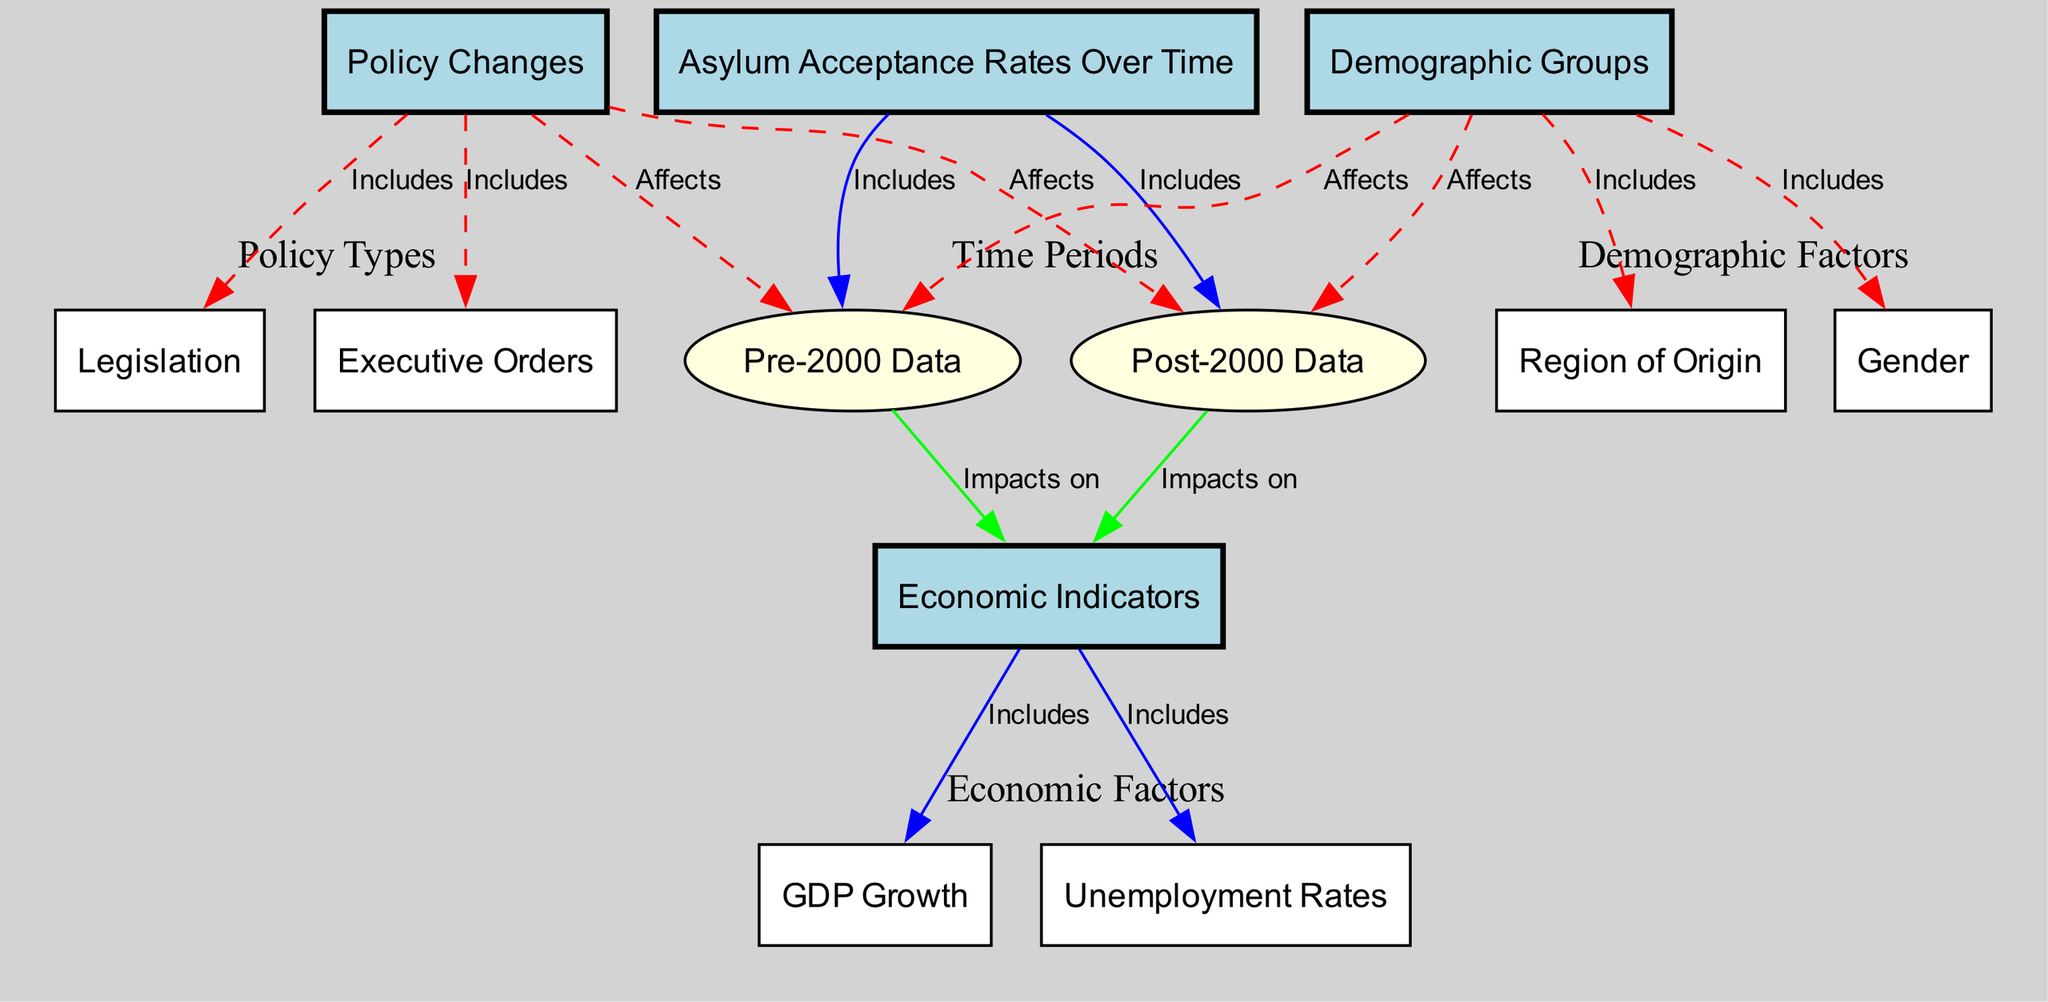What are the two main time periods represented in the diagram? The diagram highlights two distinct time periods, shown as nodes: "Pre-2000 Data" and "Post-2000 Data."
Answer: Pre-2000 Data, Post-2000 Data How many main nodes are related to economic indicators? The diagram includes two main nodes specifically related to economic indicators: "GDP Growth" and "Unemployment Rates."
Answer: 2 Which demographic factor affects both pre-2000 and post-2000 data? The diagram indicates that "Demographic Groups" affects both "Pre-2000 Data" and "Post-2000 Data" as shown by their respective edges.
Answer: Demographic Groups What type of policy change is linked to both time periods in the diagram? The diagram illustrates that "Legislation" is a type of policy change that affects both "Pre-2000 Data" and "Post-2000 Data."
Answer: Legislation Identify the relationship between "Asylum Acceptance Rates Over Time" and "Economic Indicators." The "Asylum Acceptance Rates Over Time" node is connected to the "Economic Indicators" node, indicating that acceptance rates include data from economic indicators.
Answer: Includes How do the policy changes in the diagram affect the accepted data? The diagram shows that "Policy Changes" impacts both "Pre-2000 Data" and "Post-2000 Data" through directed edges, indicating that changes in policy influence asylum acceptance over time.
Answer: Affects Which demographic group dimension is represented in the diagram? The diagram lists "Region of Origin" and "Gender" as the two demographic group dimensions affecting both time periods.
Answer: Region of Origin, Gender What color represents the economic indicators nodes in the diagram? The "GDP Growth" and "Unemployment Rates" nodes are represented in the diagram using a specific fill color which is white.
Answer: White How do economic indicators relate to the historical data periods? Both "Pre-2000 Data" and "Post-2000 Data" have edges directed towards "Economic Indicators," indicating that historical asylum acceptance rates impact economic trends.
Answer: Impacts on 